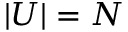<formula> <loc_0><loc_0><loc_500><loc_500>| U | = N</formula> 